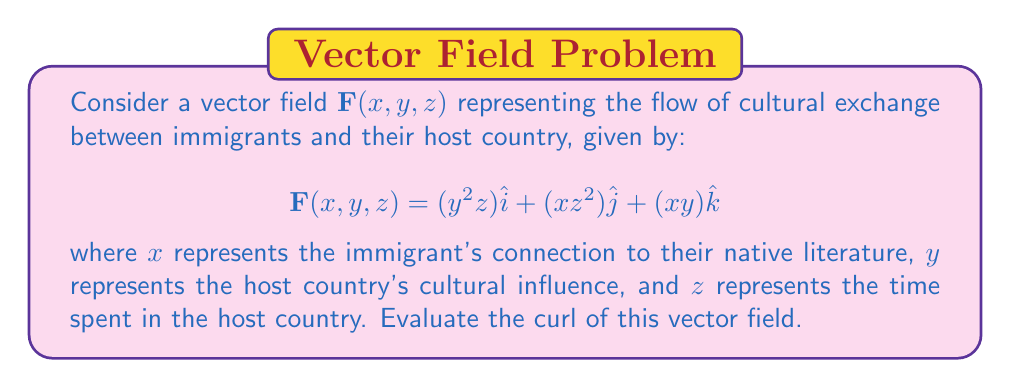Solve this math problem. To evaluate the curl of the vector field, we need to calculate:

$$\text{curl }\mathbf{F} = \nabla \times \mathbf{F} = \left(\frac{\partial F_z}{\partial y} - \frac{\partial F_y}{\partial z}\right)\hat{i} + \left(\frac{\partial F_x}{\partial z} - \frac{\partial F_z}{\partial x}\right)\hat{j} + \left(\frac{\partial F_y}{\partial x} - \frac{\partial F_x}{\partial y}\right)\hat{k}$$

Let's calculate each component:

1. $\hat{i}$ component:
   $\frac{\partial F_z}{\partial y} - \frac{\partial F_y}{\partial z} = \frac{\partial (xy)}{\partial y} - \frac{\partial (xz^2)}{\partial z} = x - 2xz$

2. $\hat{j}$ component:
   $\frac{\partial F_x}{\partial z} - \frac{\partial F_z}{\partial x} = \frac{\partial (y^2z)}{\partial z} - \frac{\partial (xy)}{\partial x} = y^2 - y$

3. $\hat{k}$ component:
   $\frac{\partial F_y}{\partial x} - \frac{\partial F_x}{\partial y} = \frac{\partial (xz^2)}{\partial x} - \frac{\partial (y^2z)}{\partial y} = z^2 - 2yz$

Combining these components, we get:

$$\text{curl }\mathbf{F} = (x - 2xz)\hat{i} + (y^2 - y)\hat{j} + (z^2 - 2yz)\hat{k}$$
Answer: $$(x - 2xz)\hat{i} + (y^2 - y)\hat{j} + (z^2 - 2yz)\hat{k}$$ 